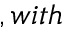Convert formula to latex. <formula><loc_0><loc_0><loc_500><loc_500>, w i t h</formula> 